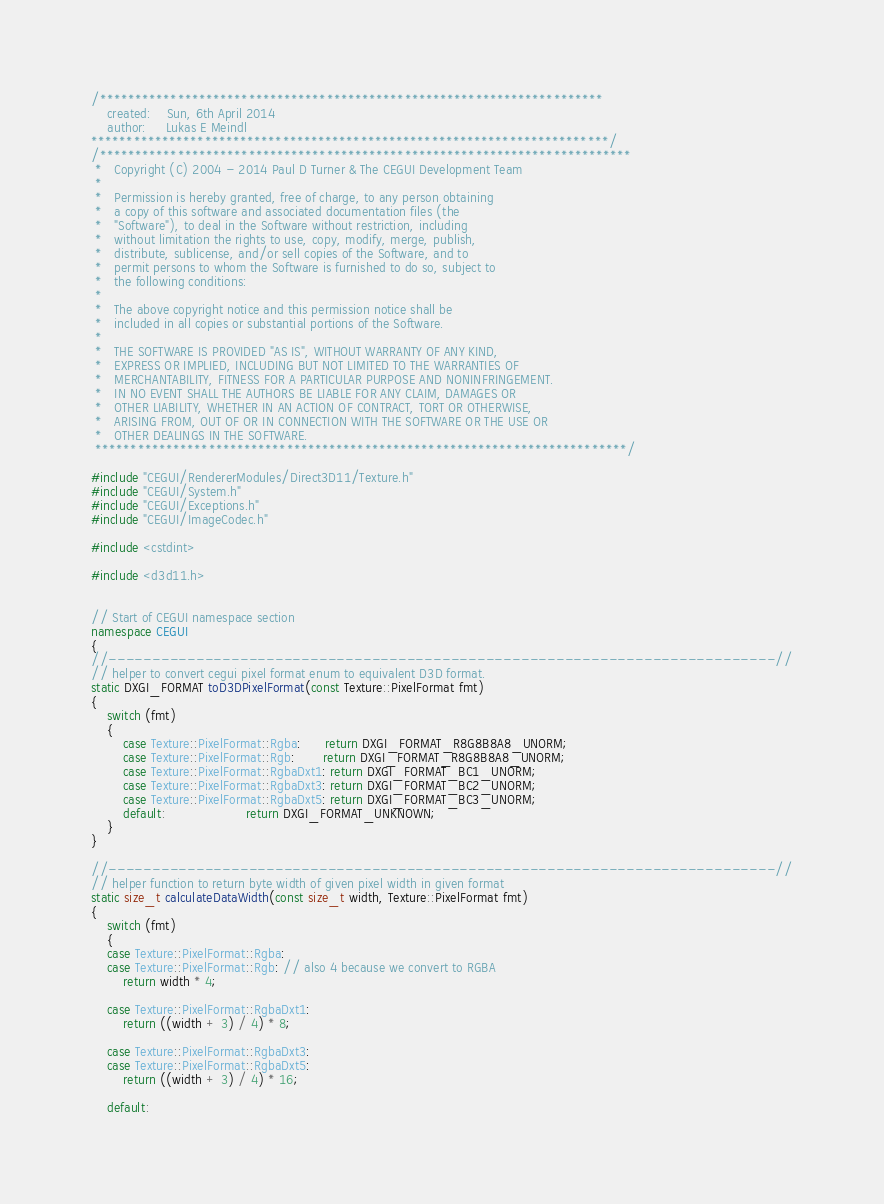Convert code to text. <code><loc_0><loc_0><loc_500><loc_500><_C++_>/***********************************************************************
    created:    Sun, 6th April 2014
    author:     Lukas E Meindl
*************************************************************************/
/***************************************************************************
 *   Copyright (C) 2004 - 2014 Paul D Turner & The CEGUI Development Team
 *
 *   Permission is hereby granted, free of charge, to any person obtaining
 *   a copy of this software and associated documentation files (the
 *   "Software"), to deal in the Software without restriction, including
 *   without limitation the rights to use, copy, modify, merge, publish,
 *   distribute, sublicense, and/or sell copies of the Software, and to
 *   permit persons to whom the Software is furnished to do so, subject to
 *   the following conditions:
 *
 *   The above copyright notice and this permission notice shall be
 *   included in all copies or substantial portions of the Software.
 *
 *   THE SOFTWARE IS PROVIDED "AS IS", WITHOUT WARRANTY OF ANY KIND,
 *   EXPRESS OR IMPLIED, INCLUDING BUT NOT LIMITED TO THE WARRANTIES OF
 *   MERCHANTABILITY, FITNESS FOR A PARTICULAR PURPOSE AND NONINFRINGEMENT.
 *   IN NO EVENT SHALL THE AUTHORS BE LIABLE FOR ANY CLAIM, DAMAGES OR
 *   OTHER LIABILITY, WHETHER IN AN ACTION OF CONTRACT, TORT OR OTHERWISE,
 *   ARISING FROM, OUT OF OR IN CONNECTION WITH THE SOFTWARE OR THE USE OR
 *   OTHER DEALINGS IN THE SOFTWARE.
 ***************************************************************************/

#include "CEGUI/RendererModules/Direct3D11/Texture.h"
#include "CEGUI/System.h"
#include "CEGUI/Exceptions.h"
#include "CEGUI/ImageCodec.h"

#include <cstdint>

#include <d3d11.h>


// Start of CEGUI namespace section
namespace CEGUI
{
//----------------------------------------------------------------------------//
// helper to convert cegui pixel format enum to equivalent D3D format.
static DXGI_FORMAT toD3DPixelFormat(const Texture::PixelFormat fmt)
{
    switch (fmt)
    {
        case Texture::PixelFormat::Rgba:      return DXGI_FORMAT_R8G8B8A8_UNORM;
        case Texture::PixelFormat::Rgb:       return DXGI_FORMAT_R8G8B8A8_UNORM;
        case Texture::PixelFormat::RgbaDxt1: return DXGI_FORMAT_BC1_UNORM;
        case Texture::PixelFormat::RgbaDxt3: return DXGI_FORMAT_BC2_UNORM;
        case Texture::PixelFormat::RgbaDxt5: return DXGI_FORMAT_BC3_UNORM;
        default:                    return DXGI_FORMAT_UNKNOWN;
    }
}

//----------------------------------------------------------------------------//
// helper function to return byte width of given pixel width in given format
static size_t calculateDataWidth(const size_t width, Texture::PixelFormat fmt)
{
    switch (fmt)
    {
    case Texture::PixelFormat::Rgba:
    case Texture::PixelFormat::Rgb: // also 4 because we convert to RGBA
        return width * 4;

    case Texture::PixelFormat::RgbaDxt1:
        return ((width + 3) / 4) * 8;

    case Texture::PixelFormat::RgbaDxt3:
    case Texture::PixelFormat::RgbaDxt5:
        return ((width + 3) / 4) * 16;

    default:</code> 